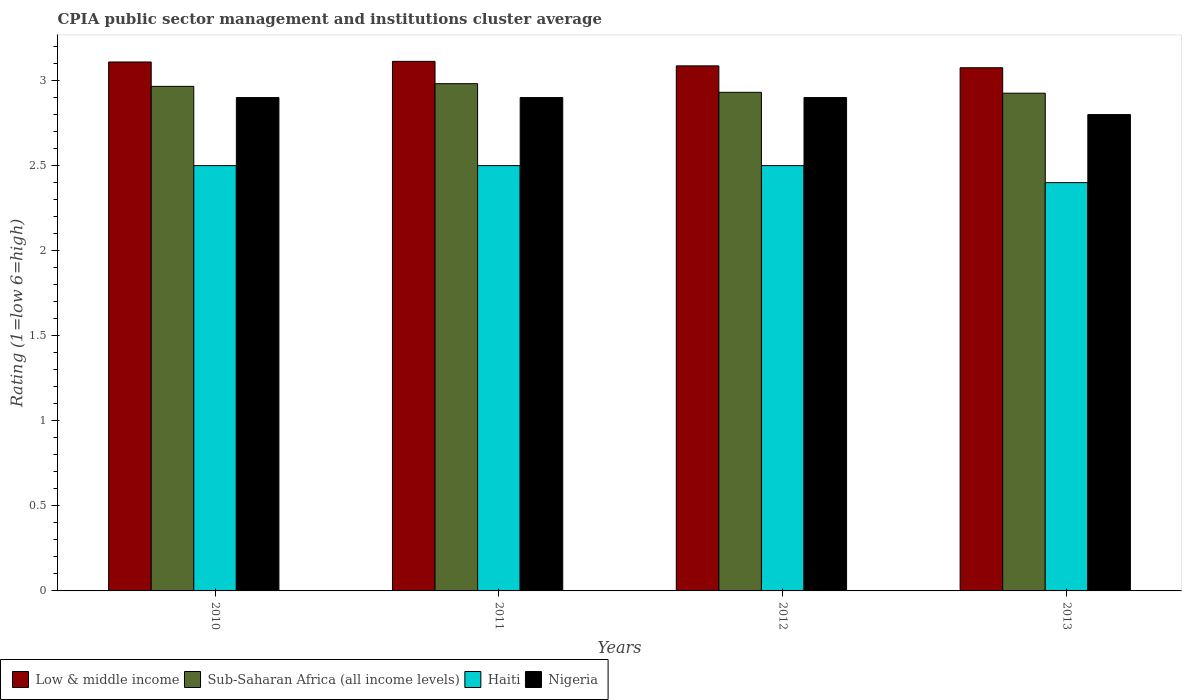How many different coloured bars are there?
Ensure brevity in your answer.  4. How many groups of bars are there?
Your answer should be very brief. 4. Are the number of bars per tick equal to the number of legend labels?
Provide a short and direct response. Yes. How many bars are there on the 4th tick from the left?
Your response must be concise. 4. How many bars are there on the 1st tick from the right?
Ensure brevity in your answer.  4. What is the label of the 2nd group of bars from the left?
Make the answer very short. 2011. In how many cases, is the number of bars for a given year not equal to the number of legend labels?
Provide a succinct answer. 0. What is the CPIA rating in Nigeria in 2011?
Make the answer very short. 2.9. Across all years, what is the minimum CPIA rating in Nigeria?
Offer a terse response. 2.8. In which year was the CPIA rating in Sub-Saharan Africa (all income levels) maximum?
Keep it short and to the point. 2011. In which year was the CPIA rating in Nigeria minimum?
Offer a terse response. 2013. What is the total CPIA rating in Sub-Saharan Africa (all income levels) in the graph?
Your response must be concise. 11.8. What is the difference between the CPIA rating in Low & middle income in 2011 and that in 2013?
Your answer should be very brief. 0.04. What is the difference between the CPIA rating in Sub-Saharan Africa (all income levels) in 2011 and the CPIA rating in Nigeria in 2012?
Give a very brief answer. 0.08. What is the average CPIA rating in Nigeria per year?
Keep it short and to the point. 2.88. In the year 2013, what is the difference between the CPIA rating in Low & middle income and CPIA rating in Nigeria?
Keep it short and to the point. 0.28. What is the ratio of the CPIA rating in Nigeria in 2010 to that in 2011?
Keep it short and to the point. 1. Is the CPIA rating in Haiti in 2010 less than that in 2011?
Provide a succinct answer. No. What is the difference between the highest and the lowest CPIA rating in Haiti?
Your answer should be very brief. 0.1. Is the sum of the CPIA rating in Haiti in 2010 and 2013 greater than the maximum CPIA rating in Nigeria across all years?
Your answer should be compact. Yes. Is it the case that in every year, the sum of the CPIA rating in Low & middle income and CPIA rating in Sub-Saharan Africa (all income levels) is greater than the sum of CPIA rating in Nigeria and CPIA rating in Haiti?
Keep it short and to the point. Yes. What does the 4th bar from the left in 2012 represents?
Your answer should be very brief. Nigeria. What does the 3rd bar from the right in 2011 represents?
Your answer should be compact. Sub-Saharan Africa (all income levels). Is it the case that in every year, the sum of the CPIA rating in Haiti and CPIA rating in Nigeria is greater than the CPIA rating in Sub-Saharan Africa (all income levels)?
Your answer should be very brief. Yes. What is the difference between two consecutive major ticks on the Y-axis?
Make the answer very short. 0.5. Does the graph contain grids?
Offer a terse response. No. Where does the legend appear in the graph?
Your answer should be compact. Bottom left. What is the title of the graph?
Your response must be concise. CPIA public sector management and institutions cluster average. What is the label or title of the X-axis?
Give a very brief answer. Years. What is the Rating (1=low 6=high) in Low & middle income in 2010?
Your answer should be very brief. 3.11. What is the Rating (1=low 6=high) in Sub-Saharan Africa (all income levels) in 2010?
Ensure brevity in your answer.  2.97. What is the Rating (1=low 6=high) in Haiti in 2010?
Offer a terse response. 2.5. What is the Rating (1=low 6=high) of Low & middle income in 2011?
Offer a very short reply. 3.11. What is the Rating (1=low 6=high) in Sub-Saharan Africa (all income levels) in 2011?
Your answer should be compact. 2.98. What is the Rating (1=low 6=high) in Low & middle income in 2012?
Ensure brevity in your answer.  3.09. What is the Rating (1=low 6=high) of Sub-Saharan Africa (all income levels) in 2012?
Provide a succinct answer. 2.93. What is the Rating (1=low 6=high) of Haiti in 2012?
Your answer should be compact. 2.5. What is the Rating (1=low 6=high) of Low & middle income in 2013?
Offer a terse response. 3.08. What is the Rating (1=low 6=high) of Sub-Saharan Africa (all income levels) in 2013?
Your answer should be very brief. 2.93. What is the Rating (1=low 6=high) of Haiti in 2013?
Your answer should be compact. 2.4. Across all years, what is the maximum Rating (1=low 6=high) of Low & middle income?
Your answer should be compact. 3.11. Across all years, what is the maximum Rating (1=low 6=high) in Sub-Saharan Africa (all income levels)?
Give a very brief answer. 2.98. Across all years, what is the maximum Rating (1=low 6=high) in Haiti?
Ensure brevity in your answer.  2.5. Across all years, what is the maximum Rating (1=low 6=high) in Nigeria?
Your answer should be compact. 2.9. Across all years, what is the minimum Rating (1=low 6=high) in Low & middle income?
Keep it short and to the point. 3.08. Across all years, what is the minimum Rating (1=low 6=high) in Sub-Saharan Africa (all income levels)?
Offer a very short reply. 2.93. Across all years, what is the minimum Rating (1=low 6=high) in Haiti?
Provide a succinct answer. 2.4. What is the total Rating (1=low 6=high) in Low & middle income in the graph?
Your answer should be compact. 12.38. What is the total Rating (1=low 6=high) of Sub-Saharan Africa (all income levels) in the graph?
Your answer should be very brief. 11.8. What is the total Rating (1=low 6=high) in Haiti in the graph?
Provide a short and direct response. 9.9. What is the difference between the Rating (1=low 6=high) of Low & middle income in 2010 and that in 2011?
Your answer should be compact. -0. What is the difference between the Rating (1=low 6=high) of Sub-Saharan Africa (all income levels) in 2010 and that in 2011?
Offer a very short reply. -0.02. What is the difference between the Rating (1=low 6=high) in Nigeria in 2010 and that in 2011?
Your answer should be very brief. 0. What is the difference between the Rating (1=low 6=high) of Low & middle income in 2010 and that in 2012?
Ensure brevity in your answer.  0.02. What is the difference between the Rating (1=low 6=high) of Sub-Saharan Africa (all income levels) in 2010 and that in 2012?
Give a very brief answer. 0.04. What is the difference between the Rating (1=low 6=high) in Haiti in 2010 and that in 2012?
Keep it short and to the point. 0. What is the difference between the Rating (1=low 6=high) of Low & middle income in 2010 and that in 2013?
Ensure brevity in your answer.  0.03. What is the difference between the Rating (1=low 6=high) of Sub-Saharan Africa (all income levels) in 2010 and that in 2013?
Give a very brief answer. 0.04. What is the difference between the Rating (1=low 6=high) in Haiti in 2010 and that in 2013?
Ensure brevity in your answer.  0.1. What is the difference between the Rating (1=low 6=high) of Nigeria in 2010 and that in 2013?
Ensure brevity in your answer.  0.1. What is the difference between the Rating (1=low 6=high) in Low & middle income in 2011 and that in 2012?
Provide a succinct answer. 0.03. What is the difference between the Rating (1=low 6=high) of Sub-Saharan Africa (all income levels) in 2011 and that in 2012?
Your answer should be very brief. 0.05. What is the difference between the Rating (1=low 6=high) of Low & middle income in 2011 and that in 2013?
Offer a terse response. 0.04. What is the difference between the Rating (1=low 6=high) of Sub-Saharan Africa (all income levels) in 2011 and that in 2013?
Provide a short and direct response. 0.06. What is the difference between the Rating (1=low 6=high) of Haiti in 2011 and that in 2013?
Your answer should be very brief. 0.1. What is the difference between the Rating (1=low 6=high) of Low & middle income in 2012 and that in 2013?
Your answer should be very brief. 0.01. What is the difference between the Rating (1=low 6=high) of Sub-Saharan Africa (all income levels) in 2012 and that in 2013?
Offer a terse response. 0.01. What is the difference between the Rating (1=low 6=high) of Low & middle income in 2010 and the Rating (1=low 6=high) of Sub-Saharan Africa (all income levels) in 2011?
Provide a succinct answer. 0.13. What is the difference between the Rating (1=low 6=high) in Low & middle income in 2010 and the Rating (1=low 6=high) in Haiti in 2011?
Make the answer very short. 0.61. What is the difference between the Rating (1=low 6=high) in Low & middle income in 2010 and the Rating (1=low 6=high) in Nigeria in 2011?
Your answer should be compact. 0.21. What is the difference between the Rating (1=low 6=high) of Sub-Saharan Africa (all income levels) in 2010 and the Rating (1=low 6=high) of Haiti in 2011?
Give a very brief answer. 0.47. What is the difference between the Rating (1=low 6=high) in Sub-Saharan Africa (all income levels) in 2010 and the Rating (1=low 6=high) in Nigeria in 2011?
Ensure brevity in your answer.  0.07. What is the difference between the Rating (1=low 6=high) of Low & middle income in 2010 and the Rating (1=low 6=high) of Sub-Saharan Africa (all income levels) in 2012?
Your response must be concise. 0.18. What is the difference between the Rating (1=low 6=high) of Low & middle income in 2010 and the Rating (1=low 6=high) of Haiti in 2012?
Your answer should be very brief. 0.61. What is the difference between the Rating (1=low 6=high) in Low & middle income in 2010 and the Rating (1=low 6=high) in Nigeria in 2012?
Your response must be concise. 0.21. What is the difference between the Rating (1=low 6=high) in Sub-Saharan Africa (all income levels) in 2010 and the Rating (1=low 6=high) in Haiti in 2012?
Give a very brief answer. 0.47. What is the difference between the Rating (1=low 6=high) in Sub-Saharan Africa (all income levels) in 2010 and the Rating (1=low 6=high) in Nigeria in 2012?
Provide a short and direct response. 0.07. What is the difference between the Rating (1=low 6=high) of Haiti in 2010 and the Rating (1=low 6=high) of Nigeria in 2012?
Provide a succinct answer. -0.4. What is the difference between the Rating (1=low 6=high) in Low & middle income in 2010 and the Rating (1=low 6=high) in Sub-Saharan Africa (all income levels) in 2013?
Keep it short and to the point. 0.18. What is the difference between the Rating (1=low 6=high) of Low & middle income in 2010 and the Rating (1=low 6=high) of Haiti in 2013?
Ensure brevity in your answer.  0.71. What is the difference between the Rating (1=low 6=high) of Low & middle income in 2010 and the Rating (1=low 6=high) of Nigeria in 2013?
Your answer should be very brief. 0.31. What is the difference between the Rating (1=low 6=high) in Sub-Saharan Africa (all income levels) in 2010 and the Rating (1=low 6=high) in Haiti in 2013?
Ensure brevity in your answer.  0.57. What is the difference between the Rating (1=low 6=high) of Sub-Saharan Africa (all income levels) in 2010 and the Rating (1=low 6=high) of Nigeria in 2013?
Keep it short and to the point. 0.17. What is the difference between the Rating (1=low 6=high) in Low & middle income in 2011 and the Rating (1=low 6=high) in Sub-Saharan Africa (all income levels) in 2012?
Your answer should be very brief. 0.18. What is the difference between the Rating (1=low 6=high) in Low & middle income in 2011 and the Rating (1=low 6=high) in Haiti in 2012?
Your answer should be compact. 0.61. What is the difference between the Rating (1=low 6=high) in Low & middle income in 2011 and the Rating (1=low 6=high) in Nigeria in 2012?
Offer a very short reply. 0.21. What is the difference between the Rating (1=low 6=high) of Sub-Saharan Africa (all income levels) in 2011 and the Rating (1=low 6=high) of Haiti in 2012?
Your response must be concise. 0.48. What is the difference between the Rating (1=low 6=high) in Sub-Saharan Africa (all income levels) in 2011 and the Rating (1=low 6=high) in Nigeria in 2012?
Ensure brevity in your answer.  0.08. What is the difference between the Rating (1=low 6=high) in Haiti in 2011 and the Rating (1=low 6=high) in Nigeria in 2012?
Offer a very short reply. -0.4. What is the difference between the Rating (1=low 6=high) of Low & middle income in 2011 and the Rating (1=low 6=high) of Sub-Saharan Africa (all income levels) in 2013?
Offer a terse response. 0.19. What is the difference between the Rating (1=low 6=high) of Low & middle income in 2011 and the Rating (1=low 6=high) of Haiti in 2013?
Your response must be concise. 0.71. What is the difference between the Rating (1=low 6=high) of Low & middle income in 2011 and the Rating (1=low 6=high) of Nigeria in 2013?
Your response must be concise. 0.31. What is the difference between the Rating (1=low 6=high) in Sub-Saharan Africa (all income levels) in 2011 and the Rating (1=low 6=high) in Haiti in 2013?
Your answer should be very brief. 0.58. What is the difference between the Rating (1=low 6=high) of Sub-Saharan Africa (all income levels) in 2011 and the Rating (1=low 6=high) of Nigeria in 2013?
Keep it short and to the point. 0.18. What is the difference between the Rating (1=low 6=high) of Low & middle income in 2012 and the Rating (1=low 6=high) of Sub-Saharan Africa (all income levels) in 2013?
Your answer should be very brief. 0.16. What is the difference between the Rating (1=low 6=high) of Low & middle income in 2012 and the Rating (1=low 6=high) of Haiti in 2013?
Offer a terse response. 0.69. What is the difference between the Rating (1=low 6=high) in Low & middle income in 2012 and the Rating (1=low 6=high) in Nigeria in 2013?
Offer a very short reply. 0.29. What is the difference between the Rating (1=low 6=high) in Sub-Saharan Africa (all income levels) in 2012 and the Rating (1=low 6=high) in Haiti in 2013?
Offer a terse response. 0.53. What is the difference between the Rating (1=low 6=high) of Sub-Saharan Africa (all income levels) in 2012 and the Rating (1=low 6=high) of Nigeria in 2013?
Your response must be concise. 0.13. What is the difference between the Rating (1=low 6=high) of Haiti in 2012 and the Rating (1=low 6=high) of Nigeria in 2013?
Ensure brevity in your answer.  -0.3. What is the average Rating (1=low 6=high) of Low & middle income per year?
Keep it short and to the point. 3.1. What is the average Rating (1=low 6=high) in Sub-Saharan Africa (all income levels) per year?
Make the answer very short. 2.95. What is the average Rating (1=low 6=high) of Haiti per year?
Your answer should be compact. 2.48. What is the average Rating (1=low 6=high) of Nigeria per year?
Keep it short and to the point. 2.88. In the year 2010, what is the difference between the Rating (1=low 6=high) of Low & middle income and Rating (1=low 6=high) of Sub-Saharan Africa (all income levels)?
Ensure brevity in your answer.  0.14. In the year 2010, what is the difference between the Rating (1=low 6=high) in Low & middle income and Rating (1=low 6=high) in Haiti?
Your answer should be very brief. 0.61. In the year 2010, what is the difference between the Rating (1=low 6=high) in Low & middle income and Rating (1=low 6=high) in Nigeria?
Provide a succinct answer. 0.21. In the year 2010, what is the difference between the Rating (1=low 6=high) of Sub-Saharan Africa (all income levels) and Rating (1=low 6=high) of Haiti?
Your response must be concise. 0.47. In the year 2010, what is the difference between the Rating (1=low 6=high) in Sub-Saharan Africa (all income levels) and Rating (1=low 6=high) in Nigeria?
Your answer should be very brief. 0.07. In the year 2011, what is the difference between the Rating (1=low 6=high) in Low & middle income and Rating (1=low 6=high) in Sub-Saharan Africa (all income levels)?
Provide a succinct answer. 0.13. In the year 2011, what is the difference between the Rating (1=low 6=high) of Low & middle income and Rating (1=low 6=high) of Haiti?
Offer a very short reply. 0.61. In the year 2011, what is the difference between the Rating (1=low 6=high) in Low & middle income and Rating (1=low 6=high) in Nigeria?
Provide a short and direct response. 0.21. In the year 2011, what is the difference between the Rating (1=low 6=high) in Sub-Saharan Africa (all income levels) and Rating (1=low 6=high) in Haiti?
Keep it short and to the point. 0.48. In the year 2011, what is the difference between the Rating (1=low 6=high) of Sub-Saharan Africa (all income levels) and Rating (1=low 6=high) of Nigeria?
Your response must be concise. 0.08. In the year 2012, what is the difference between the Rating (1=low 6=high) of Low & middle income and Rating (1=low 6=high) of Sub-Saharan Africa (all income levels)?
Offer a very short reply. 0.16. In the year 2012, what is the difference between the Rating (1=low 6=high) in Low & middle income and Rating (1=low 6=high) in Haiti?
Offer a very short reply. 0.59. In the year 2012, what is the difference between the Rating (1=low 6=high) of Low & middle income and Rating (1=low 6=high) of Nigeria?
Your response must be concise. 0.19. In the year 2012, what is the difference between the Rating (1=low 6=high) of Sub-Saharan Africa (all income levels) and Rating (1=low 6=high) of Haiti?
Offer a very short reply. 0.43. In the year 2012, what is the difference between the Rating (1=low 6=high) of Sub-Saharan Africa (all income levels) and Rating (1=low 6=high) of Nigeria?
Ensure brevity in your answer.  0.03. In the year 2013, what is the difference between the Rating (1=low 6=high) of Low & middle income and Rating (1=low 6=high) of Sub-Saharan Africa (all income levels)?
Make the answer very short. 0.15. In the year 2013, what is the difference between the Rating (1=low 6=high) in Low & middle income and Rating (1=low 6=high) in Haiti?
Offer a very short reply. 0.68. In the year 2013, what is the difference between the Rating (1=low 6=high) in Low & middle income and Rating (1=low 6=high) in Nigeria?
Your response must be concise. 0.28. In the year 2013, what is the difference between the Rating (1=low 6=high) in Sub-Saharan Africa (all income levels) and Rating (1=low 6=high) in Haiti?
Offer a very short reply. 0.53. In the year 2013, what is the difference between the Rating (1=low 6=high) of Sub-Saharan Africa (all income levels) and Rating (1=low 6=high) of Nigeria?
Offer a terse response. 0.13. In the year 2013, what is the difference between the Rating (1=low 6=high) of Haiti and Rating (1=low 6=high) of Nigeria?
Ensure brevity in your answer.  -0.4. What is the ratio of the Rating (1=low 6=high) in Low & middle income in 2010 to that in 2011?
Provide a succinct answer. 1. What is the ratio of the Rating (1=low 6=high) of Sub-Saharan Africa (all income levels) in 2010 to that in 2011?
Offer a terse response. 0.99. What is the ratio of the Rating (1=low 6=high) of Haiti in 2010 to that in 2011?
Provide a succinct answer. 1. What is the ratio of the Rating (1=low 6=high) of Nigeria in 2010 to that in 2011?
Offer a terse response. 1. What is the ratio of the Rating (1=low 6=high) of Low & middle income in 2010 to that in 2012?
Your answer should be very brief. 1.01. What is the ratio of the Rating (1=low 6=high) of Sub-Saharan Africa (all income levels) in 2010 to that in 2012?
Ensure brevity in your answer.  1.01. What is the ratio of the Rating (1=low 6=high) of Haiti in 2010 to that in 2012?
Offer a terse response. 1. What is the ratio of the Rating (1=low 6=high) in Nigeria in 2010 to that in 2012?
Offer a terse response. 1. What is the ratio of the Rating (1=low 6=high) of Sub-Saharan Africa (all income levels) in 2010 to that in 2013?
Ensure brevity in your answer.  1.01. What is the ratio of the Rating (1=low 6=high) in Haiti in 2010 to that in 2013?
Provide a short and direct response. 1.04. What is the ratio of the Rating (1=low 6=high) in Nigeria in 2010 to that in 2013?
Your answer should be compact. 1.04. What is the ratio of the Rating (1=low 6=high) in Low & middle income in 2011 to that in 2012?
Keep it short and to the point. 1.01. What is the ratio of the Rating (1=low 6=high) in Sub-Saharan Africa (all income levels) in 2011 to that in 2012?
Your answer should be very brief. 1.02. What is the ratio of the Rating (1=low 6=high) of Haiti in 2011 to that in 2012?
Your answer should be compact. 1. What is the ratio of the Rating (1=low 6=high) of Nigeria in 2011 to that in 2012?
Your answer should be very brief. 1. What is the ratio of the Rating (1=low 6=high) of Low & middle income in 2011 to that in 2013?
Provide a succinct answer. 1.01. What is the ratio of the Rating (1=low 6=high) in Sub-Saharan Africa (all income levels) in 2011 to that in 2013?
Provide a short and direct response. 1.02. What is the ratio of the Rating (1=low 6=high) of Haiti in 2011 to that in 2013?
Offer a very short reply. 1.04. What is the ratio of the Rating (1=low 6=high) in Nigeria in 2011 to that in 2013?
Offer a very short reply. 1.04. What is the ratio of the Rating (1=low 6=high) in Low & middle income in 2012 to that in 2013?
Provide a short and direct response. 1. What is the ratio of the Rating (1=low 6=high) in Sub-Saharan Africa (all income levels) in 2012 to that in 2013?
Your response must be concise. 1. What is the ratio of the Rating (1=low 6=high) of Haiti in 2012 to that in 2013?
Your response must be concise. 1.04. What is the ratio of the Rating (1=low 6=high) of Nigeria in 2012 to that in 2013?
Ensure brevity in your answer.  1.04. What is the difference between the highest and the second highest Rating (1=low 6=high) of Low & middle income?
Offer a very short reply. 0. What is the difference between the highest and the second highest Rating (1=low 6=high) in Sub-Saharan Africa (all income levels)?
Offer a terse response. 0.02. What is the difference between the highest and the second highest Rating (1=low 6=high) of Haiti?
Provide a short and direct response. 0. What is the difference between the highest and the second highest Rating (1=low 6=high) in Nigeria?
Offer a terse response. 0. What is the difference between the highest and the lowest Rating (1=low 6=high) in Low & middle income?
Offer a terse response. 0.04. What is the difference between the highest and the lowest Rating (1=low 6=high) of Sub-Saharan Africa (all income levels)?
Provide a short and direct response. 0.06. What is the difference between the highest and the lowest Rating (1=low 6=high) in Haiti?
Offer a very short reply. 0.1. What is the difference between the highest and the lowest Rating (1=low 6=high) of Nigeria?
Keep it short and to the point. 0.1. 